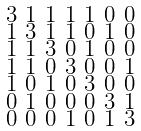Convert formula to latex. <formula><loc_0><loc_0><loc_500><loc_500>\begin{smallmatrix} 3 & 1 & 1 & 1 & 1 & 0 & 0 \\ 1 & 3 & 1 & 1 & 0 & 1 & 0 \\ 1 & 1 & 3 & 0 & 1 & 0 & 0 \\ 1 & 1 & 0 & 3 & 0 & 0 & 1 \\ 1 & 0 & 1 & 0 & 3 & 0 & 0 \\ 0 & 1 & 0 & 0 & 0 & 3 & 1 \\ 0 & 0 & 0 & 1 & 0 & 1 & 3 \end{smallmatrix}</formula> 